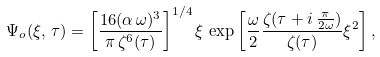<formula> <loc_0><loc_0><loc_500><loc_500>\Psi _ { o } ( \xi , \, \tau ) = \left [ \frac { 1 6 ( \alpha \, \omega ) ^ { 3 } } { \pi \, \zeta ^ { 6 } ( \tau ) } \right ] ^ { 1 / 4 } \xi \, \exp \left [ \frac { \omega } { 2 } \frac { \zeta ( \tau + i \, \frac { \pi } { 2 \omega } ) } { \zeta ( \tau ) } \xi ^ { 2 } \right ] ,</formula> 